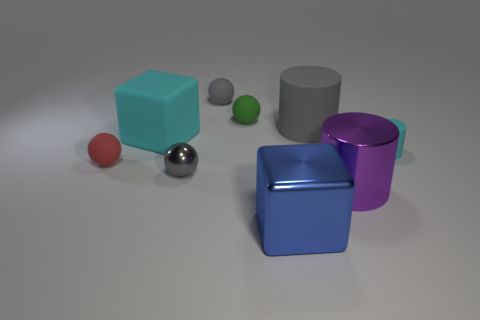Could you describe the textures visible in the image? The objects appear to have a smooth, matte finish, with subtle reflections indicating a non-glossy surface texture. The flooring has a very fine texture that contrasts with the smoothness of the geometric shapes. 